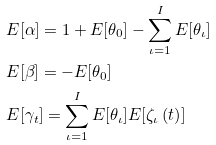Convert formula to latex. <formula><loc_0><loc_0><loc_500><loc_500>& E [ \alpha ] = 1 + E [ \theta _ { 0 } ] - \sum _ { \iota = 1 } ^ { I } E [ \theta _ { \iota } ] \\ & E [ \beta ] = - E [ \theta _ { 0 } ] \\ & E [ \gamma _ { t } ] = \sum _ { \iota = 1 } ^ { I } E [ \theta _ { \iota } ] E [ \zeta _ { \iota } \left ( t \right ) ]</formula> 